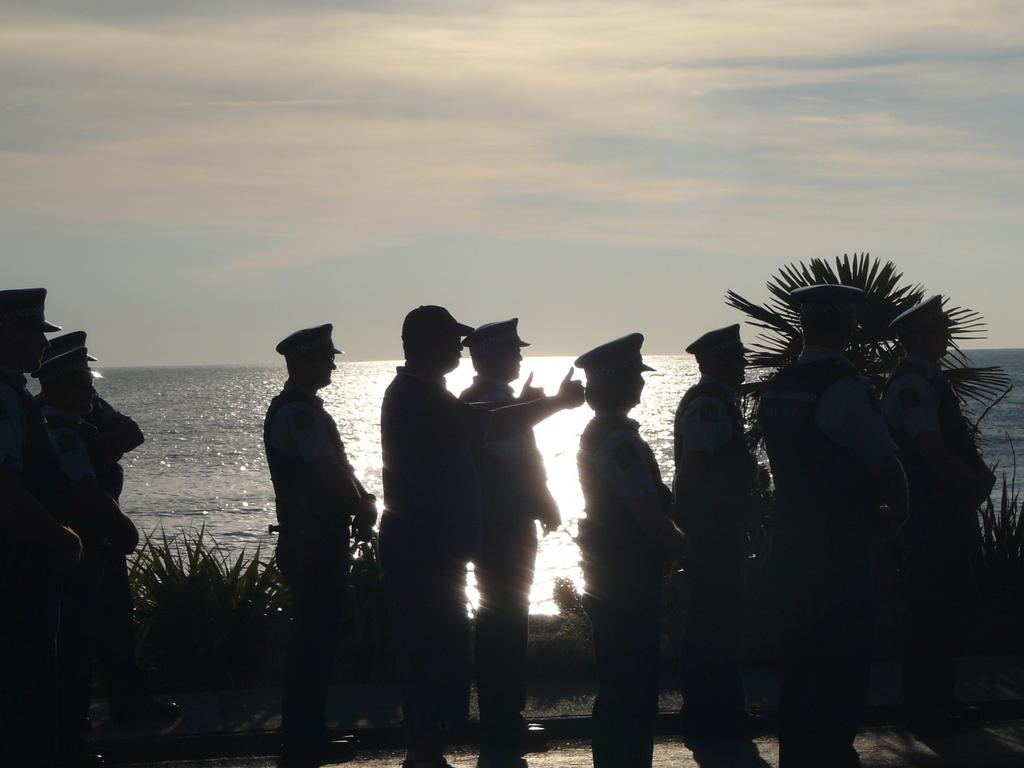What can be seen in the center of the image? There are persons standing in the center of the image. What type of vegetation is present in the image? There are plants in the image. What natural setting is visible in the background of the image? There is a beach in the background of the image. What is visible at the top of the image? The sky is visible at the top of the image. Can you tell me how many snails are crawling on the persons' legs in the image? There are no snails present in the image; the persons' legs are not shown. 